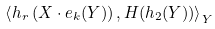<formula> <loc_0><loc_0><loc_500><loc_500>\left \langle h _ { r } \left ( X \cdot e _ { k } ( Y ) \right ) , H ( h _ { 2 } ( Y ) ) \right \rangle _ { Y }</formula> 